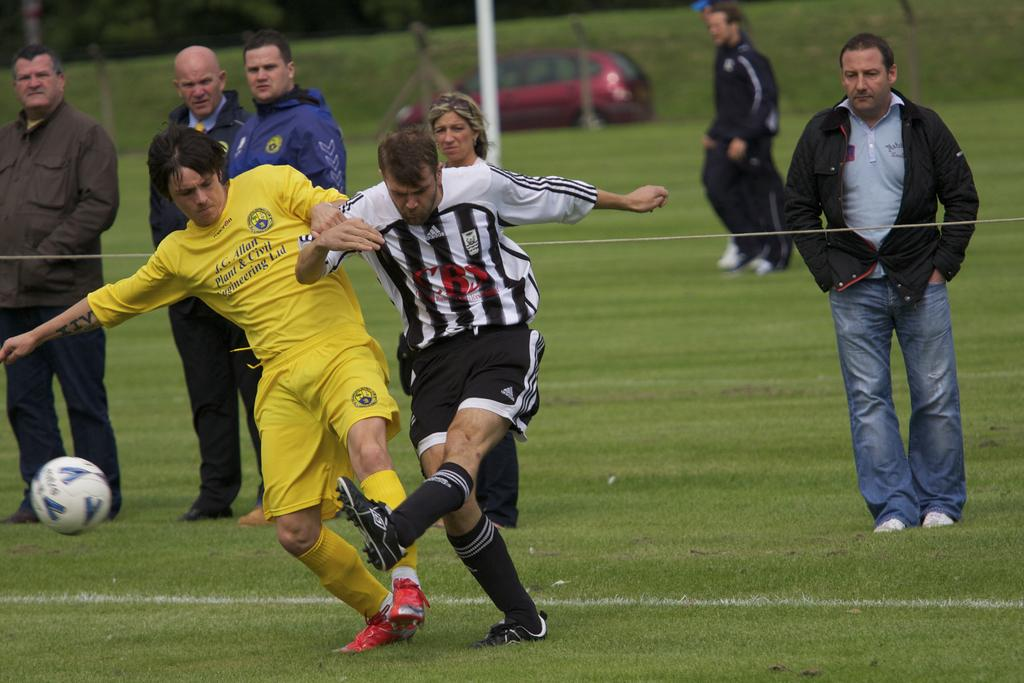What activity are the people in the image engaged in? The people in the image are playing football. What can be seen in the background of the image? There are people standing in the backdrop of the image. What type of vehicle is present in the image? There is a vehicle in the image. What is the surface on which the football game is being played? There is grass on the floor in the image. What type of connection is being used by the football players in the image? There is no mention of a connection in the image; the football players are playing on a grassy field. What story is being told by the people standing in the backdrop of the image? There is no story being told by the people standing in the backdrop; they are simply present in the image. 